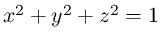Convert formula to latex. <formula><loc_0><loc_0><loc_500><loc_500>x ^ { 2 } + y ^ { 2 } + z ^ { 2 } = 1</formula> 